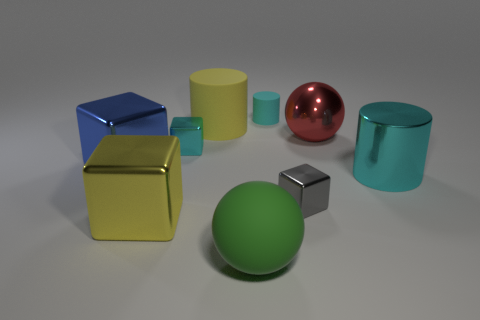Subtract all green spheres. How many cyan cylinders are left? 2 Subtract all large cylinders. How many cylinders are left? 1 Subtract all yellow blocks. How many blocks are left? 3 Subtract 1 cylinders. How many cylinders are left? 2 Subtract all brown blocks. Subtract all brown spheres. How many blocks are left? 4 Add 7 blue blocks. How many blue blocks are left? 8 Add 3 blue rubber things. How many blue rubber things exist? 3 Subtract 0 green cubes. How many objects are left? 9 Subtract all blocks. How many objects are left? 5 Subtract all yellow objects. Subtract all cyan cylinders. How many objects are left? 5 